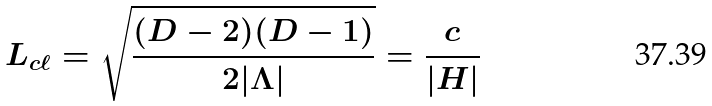Convert formula to latex. <formula><loc_0><loc_0><loc_500><loc_500>L _ { c \ell } = \sqrt { \frac { ( D - 2 ) ( D - 1 ) } { 2 | \Lambda | } } = \frac { c } { | H | }</formula> 